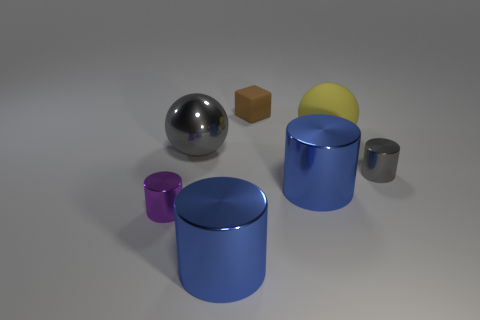Subtract all blue spheres. How many blue cylinders are left? 2 Subtract all purple cylinders. How many cylinders are left? 3 Subtract 1 cylinders. How many cylinders are left? 3 Add 1 blue metal cubes. How many objects exist? 8 Subtract all gray cylinders. How many cylinders are left? 3 Subtract all red cylinders. Subtract all purple spheres. How many cylinders are left? 4 Subtract all cubes. How many objects are left? 6 Add 7 small cubes. How many small cubes are left? 8 Add 7 blue metal cylinders. How many blue metal cylinders exist? 9 Subtract 1 purple cylinders. How many objects are left? 6 